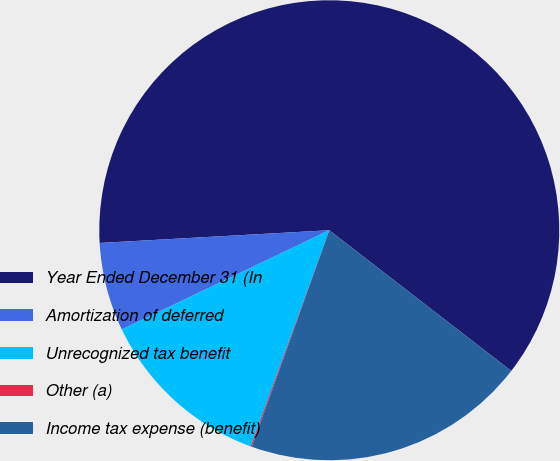<chart> <loc_0><loc_0><loc_500><loc_500><pie_chart><fcel>Year Ended December 31 (In<fcel>Amortization of deferred<fcel>Unrecognized tax benefit<fcel>Other (a)<fcel>Income tax expense (benefit)<nl><fcel>61.35%<fcel>6.22%<fcel>12.34%<fcel>0.09%<fcel>19.99%<nl></chart> 